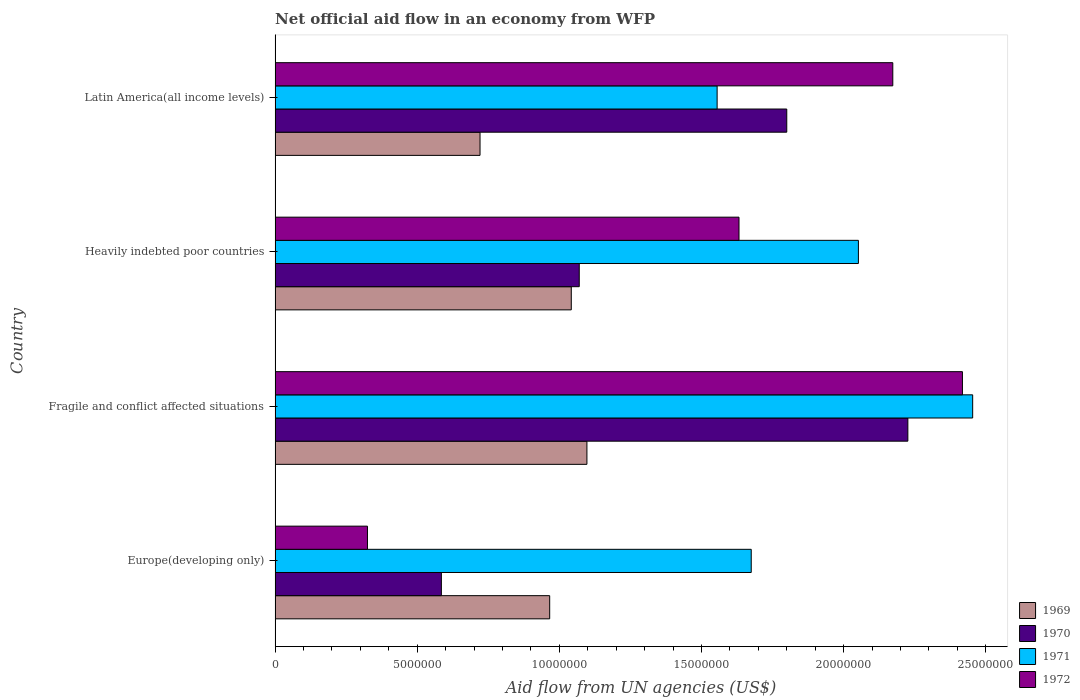How many different coloured bars are there?
Your answer should be very brief. 4. Are the number of bars per tick equal to the number of legend labels?
Ensure brevity in your answer.  Yes. Are the number of bars on each tick of the Y-axis equal?
Provide a short and direct response. Yes. How many bars are there on the 4th tick from the top?
Keep it short and to the point. 4. What is the label of the 1st group of bars from the top?
Offer a very short reply. Latin America(all income levels). In how many cases, is the number of bars for a given country not equal to the number of legend labels?
Your answer should be very brief. 0. What is the net official aid flow in 1969 in Latin America(all income levels)?
Keep it short and to the point. 7.21e+06. Across all countries, what is the maximum net official aid flow in 1972?
Provide a short and direct response. 2.42e+07. Across all countries, what is the minimum net official aid flow in 1969?
Your response must be concise. 7.21e+06. In which country was the net official aid flow in 1969 maximum?
Provide a succinct answer. Fragile and conflict affected situations. In which country was the net official aid flow in 1969 minimum?
Offer a terse response. Latin America(all income levels). What is the total net official aid flow in 1969 in the graph?
Provide a short and direct response. 3.83e+07. What is the difference between the net official aid flow in 1969 in Fragile and conflict affected situations and that in Latin America(all income levels)?
Your answer should be compact. 3.76e+06. What is the difference between the net official aid flow in 1969 in Heavily indebted poor countries and the net official aid flow in 1972 in Latin America(all income levels)?
Provide a succinct answer. -1.13e+07. What is the average net official aid flow in 1969 per country?
Provide a succinct answer. 9.56e+06. What is the difference between the net official aid flow in 1972 and net official aid flow in 1970 in Latin America(all income levels)?
Offer a very short reply. 3.73e+06. In how many countries, is the net official aid flow in 1971 greater than 8000000 US$?
Offer a very short reply. 4. What is the ratio of the net official aid flow in 1969 in Europe(developing only) to that in Fragile and conflict affected situations?
Your response must be concise. 0.88. Is the difference between the net official aid flow in 1972 in Heavily indebted poor countries and Latin America(all income levels) greater than the difference between the net official aid flow in 1970 in Heavily indebted poor countries and Latin America(all income levels)?
Your response must be concise. Yes. What is the difference between the highest and the second highest net official aid flow in 1970?
Make the answer very short. 4.26e+06. What is the difference between the highest and the lowest net official aid flow in 1970?
Your answer should be very brief. 1.64e+07. Is it the case that in every country, the sum of the net official aid flow in 1972 and net official aid flow in 1971 is greater than the sum of net official aid flow in 1970 and net official aid flow in 1969?
Your answer should be compact. No. What does the 4th bar from the top in Latin America(all income levels) represents?
Offer a very short reply. 1969. What does the 1st bar from the bottom in Heavily indebted poor countries represents?
Offer a terse response. 1969. How many bars are there?
Provide a succinct answer. 16. What is the difference between two consecutive major ticks on the X-axis?
Keep it short and to the point. 5.00e+06. Does the graph contain any zero values?
Provide a short and direct response. No. Where does the legend appear in the graph?
Make the answer very short. Bottom right. How are the legend labels stacked?
Provide a succinct answer. Vertical. What is the title of the graph?
Keep it short and to the point. Net official aid flow in an economy from WFP. What is the label or title of the X-axis?
Your response must be concise. Aid flow from UN agencies (US$). What is the label or title of the Y-axis?
Your response must be concise. Country. What is the Aid flow from UN agencies (US$) in 1969 in Europe(developing only)?
Make the answer very short. 9.66e+06. What is the Aid flow from UN agencies (US$) in 1970 in Europe(developing only)?
Your answer should be compact. 5.85e+06. What is the Aid flow from UN agencies (US$) of 1971 in Europe(developing only)?
Keep it short and to the point. 1.68e+07. What is the Aid flow from UN agencies (US$) of 1972 in Europe(developing only)?
Provide a succinct answer. 3.25e+06. What is the Aid flow from UN agencies (US$) in 1969 in Fragile and conflict affected situations?
Your answer should be very brief. 1.10e+07. What is the Aid flow from UN agencies (US$) of 1970 in Fragile and conflict affected situations?
Provide a short and direct response. 2.23e+07. What is the Aid flow from UN agencies (US$) in 1971 in Fragile and conflict affected situations?
Provide a succinct answer. 2.45e+07. What is the Aid flow from UN agencies (US$) of 1972 in Fragile and conflict affected situations?
Provide a short and direct response. 2.42e+07. What is the Aid flow from UN agencies (US$) in 1969 in Heavily indebted poor countries?
Make the answer very short. 1.04e+07. What is the Aid flow from UN agencies (US$) of 1970 in Heavily indebted poor countries?
Offer a terse response. 1.07e+07. What is the Aid flow from UN agencies (US$) of 1971 in Heavily indebted poor countries?
Ensure brevity in your answer.  2.05e+07. What is the Aid flow from UN agencies (US$) in 1972 in Heavily indebted poor countries?
Make the answer very short. 1.63e+07. What is the Aid flow from UN agencies (US$) in 1969 in Latin America(all income levels)?
Your response must be concise. 7.21e+06. What is the Aid flow from UN agencies (US$) of 1970 in Latin America(all income levels)?
Your answer should be compact. 1.80e+07. What is the Aid flow from UN agencies (US$) of 1971 in Latin America(all income levels)?
Make the answer very short. 1.56e+07. What is the Aid flow from UN agencies (US$) of 1972 in Latin America(all income levels)?
Provide a succinct answer. 2.17e+07. Across all countries, what is the maximum Aid flow from UN agencies (US$) in 1969?
Your answer should be compact. 1.10e+07. Across all countries, what is the maximum Aid flow from UN agencies (US$) in 1970?
Your answer should be very brief. 2.23e+07. Across all countries, what is the maximum Aid flow from UN agencies (US$) of 1971?
Offer a terse response. 2.45e+07. Across all countries, what is the maximum Aid flow from UN agencies (US$) of 1972?
Your answer should be very brief. 2.42e+07. Across all countries, what is the minimum Aid flow from UN agencies (US$) of 1969?
Provide a short and direct response. 7.21e+06. Across all countries, what is the minimum Aid flow from UN agencies (US$) in 1970?
Offer a very short reply. 5.85e+06. Across all countries, what is the minimum Aid flow from UN agencies (US$) of 1971?
Your answer should be compact. 1.56e+07. Across all countries, what is the minimum Aid flow from UN agencies (US$) of 1972?
Offer a very short reply. 3.25e+06. What is the total Aid flow from UN agencies (US$) in 1969 in the graph?
Give a very brief answer. 3.83e+07. What is the total Aid flow from UN agencies (US$) in 1970 in the graph?
Your answer should be very brief. 5.68e+07. What is the total Aid flow from UN agencies (US$) of 1971 in the graph?
Your answer should be very brief. 7.74e+07. What is the total Aid flow from UN agencies (US$) in 1972 in the graph?
Your answer should be very brief. 6.55e+07. What is the difference between the Aid flow from UN agencies (US$) of 1969 in Europe(developing only) and that in Fragile and conflict affected situations?
Your response must be concise. -1.31e+06. What is the difference between the Aid flow from UN agencies (US$) in 1970 in Europe(developing only) and that in Fragile and conflict affected situations?
Your answer should be compact. -1.64e+07. What is the difference between the Aid flow from UN agencies (US$) in 1971 in Europe(developing only) and that in Fragile and conflict affected situations?
Provide a succinct answer. -7.79e+06. What is the difference between the Aid flow from UN agencies (US$) of 1972 in Europe(developing only) and that in Fragile and conflict affected situations?
Offer a terse response. -2.09e+07. What is the difference between the Aid flow from UN agencies (US$) in 1969 in Europe(developing only) and that in Heavily indebted poor countries?
Your answer should be very brief. -7.60e+05. What is the difference between the Aid flow from UN agencies (US$) of 1970 in Europe(developing only) and that in Heavily indebted poor countries?
Make the answer very short. -4.85e+06. What is the difference between the Aid flow from UN agencies (US$) of 1971 in Europe(developing only) and that in Heavily indebted poor countries?
Provide a succinct answer. -3.77e+06. What is the difference between the Aid flow from UN agencies (US$) of 1972 in Europe(developing only) and that in Heavily indebted poor countries?
Ensure brevity in your answer.  -1.31e+07. What is the difference between the Aid flow from UN agencies (US$) of 1969 in Europe(developing only) and that in Latin America(all income levels)?
Provide a succinct answer. 2.45e+06. What is the difference between the Aid flow from UN agencies (US$) in 1970 in Europe(developing only) and that in Latin America(all income levels)?
Keep it short and to the point. -1.22e+07. What is the difference between the Aid flow from UN agencies (US$) in 1971 in Europe(developing only) and that in Latin America(all income levels)?
Give a very brief answer. 1.20e+06. What is the difference between the Aid flow from UN agencies (US$) of 1972 in Europe(developing only) and that in Latin America(all income levels)?
Your response must be concise. -1.85e+07. What is the difference between the Aid flow from UN agencies (US$) in 1969 in Fragile and conflict affected situations and that in Heavily indebted poor countries?
Keep it short and to the point. 5.50e+05. What is the difference between the Aid flow from UN agencies (US$) of 1970 in Fragile and conflict affected situations and that in Heavily indebted poor countries?
Your answer should be compact. 1.16e+07. What is the difference between the Aid flow from UN agencies (US$) in 1971 in Fragile and conflict affected situations and that in Heavily indebted poor countries?
Give a very brief answer. 4.02e+06. What is the difference between the Aid flow from UN agencies (US$) in 1972 in Fragile and conflict affected situations and that in Heavily indebted poor countries?
Keep it short and to the point. 7.86e+06. What is the difference between the Aid flow from UN agencies (US$) of 1969 in Fragile and conflict affected situations and that in Latin America(all income levels)?
Your response must be concise. 3.76e+06. What is the difference between the Aid flow from UN agencies (US$) of 1970 in Fragile and conflict affected situations and that in Latin America(all income levels)?
Provide a short and direct response. 4.26e+06. What is the difference between the Aid flow from UN agencies (US$) of 1971 in Fragile and conflict affected situations and that in Latin America(all income levels)?
Your answer should be compact. 8.99e+06. What is the difference between the Aid flow from UN agencies (US$) of 1972 in Fragile and conflict affected situations and that in Latin America(all income levels)?
Give a very brief answer. 2.45e+06. What is the difference between the Aid flow from UN agencies (US$) of 1969 in Heavily indebted poor countries and that in Latin America(all income levels)?
Give a very brief answer. 3.21e+06. What is the difference between the Aid flow from UN agencies (US$) of 1970 in Heavily indebted poor countries and that in Latin America(all income levels)?
Provide a succinct answer. -7.30e+06. What is the difference between the Aid flow from UN agencies (US$) in 1971 in Heavily indebted poor countries and that in Latin America(all income levels)?
Ensure brevity in your answer.  4.97e+06. What is the difference between the Aid flow from UN agencies (US$) of 1972 in Heavily indebted poor countries and that in Latin America(all income levels)?
Make the answer very short. -5.41e+06. What is the difference between the Aid flow from UN agencies (US$) in 1969 in Europe(developing only) and the Aid flow from UN agencies (US$) in 1970 in Fragile and conflict affected situations?
Offer a very short reply. -1.26e+07. What is the difference between the Aid flow from UN agencies (US$) of 1969 in Europe(developing only) and the Aid flow from UN agencies (US$) of 1971 in Fragile and conflict affected situations?
Keep it short and to the point. -1.49e+07. What is the difference between the Aid flow from UN agencies (US$) in 1969 in Europe(developing only) and the Aid flow from UN agencies (US$) in 1972 in Fragile and conflict affected situations?
Your answer should be compact. -1.45e+07. What is the difference between the Aid flow from UN agencies (US$) in 1970 in Europe(developing only) and the Aid flow from UN agencies (US$) in 1971 in Fragile and conflict affected situations?
Provide a short and direct response. -1.87e+07. What is the difference between the Aid flow from UN agencies (US$) in 1970 in Europe(developing only) and the Aid flow from UN agencies (US$) in 1972 in Fragile and conflict affected situations?
Your answer should be very brief. -1.83e+07. What is the difference between the Aid flow from UN agencies (US$) of 1971 in Europe(developing only) and the Aid flow from UN agencies (US$) of 1972 in Fragile and conflict affected situations?
Your response must be concise. -7.43e+06. What is the difference between the Aid flow from UN agencies (US$) of 1969 in Europe(developing only) and the Aid flow from UN agencies (US$) of 1970 in Heavily indebted poor countries?
Keep it short and to the point. -1.04e+06. What is the difference between the Aid flow from UN agencies (US$) of 1969 in Europe(developing only) and the Aid flow from UN agencies (US$) of 1971 in Heavily indebted poor countries?
Your answer should be compact. -1.09e+07. What is the difference between the Aid flow from UN agencies (US$) in 1969 in Europe(developing only) and the Aid flow from UN agencies (US$) in 1972 in Heavily indebted poor countries?
Your response must be concise. -6.66e+06. What is the difference between the Aid flow from UN agencies (US$) of 1970 in Europe(developing only) and the Aid flow from UN agencies (US$) of 1971 in Heavily indebted poor countries?
Your response must be concise. -1.47e+07. What is the difference between the Aid flow from UN agencies (US$) of 1970 in Europe(developing only) and the Aid flow from UN agencies (US$) of 1972 in Heavily indebted poor countries?
Provide a succinct answer. -1.05e+07. What is the difference between the Aid flow from UN agencies (US$) of 1969 in Europe(developing only) and the Aid flow from UN agencies (US$) of 1970 in Latin America(all income levels)?
Your answer should be compact. -8.34e+06. What is the difference between the Aid flow from UN agencies (US$) of 1969 in Europe(developing only) and the Aid flow from UN agencies (US$) of 1971 in Latin America(all income levels)?
Keep it short and to the point. -5.89e+06. What is the difference between the Aid flow from UN agencies (US$) of 1969 in Europe(developing only) and the Aid flow from UN agencies (US$) of 1972 in Latin America(all income levels)?
Ensure brevity in your answer.  -1.21e+07. What is the difference between the Aid flow from UN agencies (US$) of 1970 in Europe(developing only) and the Aid flow from UN agencies (US$) of 1971 in Latin America(all income levels)?
Give a very brief answer. -9.70e+06. What is the difference between the Aid flow from UN agencies (US$) in 1970 in Europe(developing only) and the Aid flow from UN agencies (US$) in 1972 in Latin America(all income levels)?
Offer a terse response. -1.59e+07. What is the difference between the Aid flow from UN agencies (US$) of 1971 in Europe(developing only) and the Aid flow from UN agencies (US$) of 1972 in Latin America(all income levels)?
Your answer should be compact. -4.98e+06. What is the difference between the Aid flow from UN agencies (US$) of 1969 in Fragile and conflict affected situations and the Aid flow from UN agencies (US$) of 1971 in Heavily indebted poor countries?
Your answer should be compact. -9.55e+06. What is the difference between the Aid flow from UN agencies (US$) of 1969 in Fragile and conflict affected situations and the Aid flow from UN agencies (US$) of 1972 in Heavily indebted poor countries?
Provide a succinct answer. -5.35e+06. What is the difference between the Aid flow from UN agencies (US$) of 1970 in Fragile and conflict affected situations and the Aid flow from UN agencies (US$) of 1971 in Heavily indebted poor countries?
Keep it short and to the point. 1.74e+06. What is the difference between the Aid flow from UN agencies (US$) of 1970 in Fragile and conflict affected situations and the Aid flow from UN agencies (US$) of 1972 in Heavily indebted poor countries?
Your answer should be compact. 5.94e+06. What is the difference between the Aid flow from UN agencies (US$) of 1971 in Fragile and conflict affected situations and the Aid flow from UN agencies (US$) of 1972 in Heavily indebted poor countries?
Your answer should be compact. 8.22e+06. What is the difference between the Aid flow from UN agencies (US$) of 1969 in Fragile and conflict affected situations and the Aid flow from UN agencies (US$) of 1970 in Latin America(all income levels)?
Keep it short and to the point. -7.03e+06. What is the difference between the Aid flow from UN agencies (US$) in 1969 in Fragile and conflict affected situations and the Aid flow from UN agencies (US$) in 1971 in Latin America(all income levels)?
Keep it short and to the point. -4.58e+06. What is the difference between the Aid flow from UN agencies (US$) in 1969 in Fragile and conflict affected situations and the Aid flow from UN agencies (US$) in 1972 in Latin America(all income levels)?
Your answer should be compact. -1.08e+07. What is the difference between the Aid flow from UN agencies (US$) in 1970 in Fragile and conflict affected situations and the Aid flow from UN agencies (US$) in 1971 in Latin America(all income levels)?
Offer a terse response. 6.71e+06. What is the difference between the Aid flow from UN agencies (US$) of 1970 in Fragile and conflict affected situations and the Aid flow from UN agencies (US$) of 1972 in Latin America(all income levels)?
Your response must be concise. 5.30e+05. What is the difference between the Aid flow from UN agencies (US$) in 1971 in Fragile and conflict affected situations and the Aid flow from UN agencies (US$) in 1972 in Latin America(all income levels)?
Provide a short and direct response. 2.81e+06. What is the difference between the Aid flow from UN agencies (US$) in 1969 in Heavily indebted poor countries and the Aid flow from UN agencies (US$) in 1970 in Latin America(all income levels)?
Make the answer very short. -7.58e+06. What is the difference between the Aid flow from UN agencies (US$) in 1969 in Heavily indebted poor countries and the Aid flow from UN agencies (US$) in 1971 in Latin America(all income levels)?
Provide a succinct answer. -5.13e+06. What is the difference between the Aid flow from UN agencies (US$) in 1969 in Heavily indebted poor countries and the Aid flow from UN agencies (US$) in 1972 in Latin America(all income levels)?
Offer a very short reply. -1.13e+07. What is the difference between the Aid flow from UN agencies (US$) in 1970 in Heavily indebted poor countries and the Aid flow from UN agencies (US$) in 1971 in Latin America(all income levels)?
Your answer should be compact. -4.85e+06. What is the difference between the Aid flow from UN agencies (US$) of 1970 in Heavily indebted poor countries and the Aid flow from UN agencies (US$) of 1972 in Latin America(all income levels)?
Give a very brief answer. -1.10e+07. What is the difference between the Aid flow from UN agencies (US$) in 1971 in Heavily indebted poor countries and the Aid flow from UN agencies (US$) in 1972 in Latin America(all income levels)?
Your response must be concise. -1.21e+06. What is the average Aid flow from UN agencies (US$) in 1969 per country?
Your response must be concise. 9.56e+06. What is the average Aid flow from UN agencies (US$) of 1970 per country?
Offer a very short reply. 1.42e+07. What is the average Aid flow from UN agencies (US$) of 1971 per country?
Offer a very short reply. 1.93e+07. What is the average Aid flow from UN agencies (US$) in 1972 per country?
Provide a short and direct response. 1.64e+07. What is the difference between the Aid flow from UN agencies (US$) of 1969 and Aid flow from UN agencies (US$) of 1970 in Europe(developing only)?
Offer a terse response. 3.81e+06. What is the difference between the Aid flow from UN agencies (US$) in 1969 and Aid flow from UN agencies (US$) in 1971 in Europe(developing only)?
Keep it short and to the point. -7.09e+06. What is the difference between the Aid flow from UN agencies (US$) in 1969 and Aid flow from UN agencies (US$) in 1972 in Europe(developing only)?
Make the answer very short. 6.41e+06. What is the difference between the Aid flow from UN agencies (US$) in 1970 and Aid flow from UN agencies (US$) in 1971 in Europe(developing only)?
Offer a very short reply. -1.09e+07. What is the difference between the Aid flow from UN agencies (US$) of 1970 and Aid flow from UN agencies (US$) of 1972 in Europe(developing only)?
Provide a succinct answer. 2.60e+06. What is the difference between the Aid flow from UN agencies (US$) in 1971 and Aid flow from UN agencies (US$) in 1972 in Europe(developing only)?
Keep it short and to the point. 1.35e+07. What is the difference between the Aid flow from UN agencies (US$) in 1969 and Aid flow from UN agencies (US$) in 1970 in Fragile and conflict affected situations?
Your answer should be very brief. -1.13e+07. What is the difference between the Aid flow from UN agencies (US$) of 1969 and Aid flow from UN agencies (US$) of 1971 in Fragile and conflict affected situations?
Your response must be concise. -1.36e+07. What is the difference between the Aid flow from UN agencies (US$) of 1969 and Aid flow from UN agencies (US$) of 1972 in Fragile and conflict affected situations?
Keep it short and to the point. -1.32e+07. What is the difference between the Aid flow from UN agencies (US$) of 1970 and Aid flow from UN agencies (US$) of 1971 in Fragile and conflict affected situations?
Make the answer very short. -2.28e+06. What is the difference between the Aid flow from UN agencies (US$) of 1970 and Aid flow from UN agencies (US$) of 1972 in Fragile and conflict affected situations?
Provide a short and direct response. -1.92e+06. What is the difference between the Aid flow from UN agencies (US$) in 1969 and Aid flow from UN agencies (US$) in 1970 in Heavily indebted poor countries?
Ensure brevity in your answer.  -2.80e+05. What is the difference between the Aid flow from UN agencies (US$) in 1969 and Aid flow from UN agencies (US$) in 1971 in Heavily indebted poor countries?
Your answer should be very brief. -1.01e+07. What is the difference between the Aid flow from UN agencies (US$) in 1969 and Aid flow from UN agencies (US$) in 1972 in Heavily indebted poor countries?
Give a very brief answer. -5.90e+06. What is the difference between the Aid flow from UN agencies (US$) in 1970 and Aid flow from UN agencies (US$) in 1971 in Heavily indebted poor countries?
Make the answer very short. -9.82e+06. What is the difference between the Aid flow from UN agencies (US$) of 1970 and Aid flow from UN agencies (US$) of 1972 in Heavily indebted poor countries?
Your answer should be very brief. -5.62e+06. What is the difference between the Aid flow from UN agencies (US$) in 1971 and Aid flow from UN agencies (US$) in 1972 in Heavily indebted poor countries?
Offer a terse response. 4.20e+06. What is the difference between the Aid flow from UN agencies (US$) in 1969 and Aid flow from UN agencies (US$) in 1970 in Latin America(all income levels)?
Your answer should be compact. -1.08e+07. What is the difference between the Aid flow from UN agencies (US$) of 1969 and Aid flow from UN agencies (US$) of 1971 in Latin America(all income levels)?
Provide a succinct answer. -8.34e+06. What is the difference between the Aid flow from UN agencies (US$) of 1969 and Aid flow from UN agencies (US$) of 1972 in Latin America(all income levels)?
Offer a very short reply. -1.45e+07. What is the difference between the Aid flow from UN agencies (US$) of 1970 and Aid flow from UN agencies (US$) of 1971 in Latin America(all income levels)?
Ensure brevity in your answer.  2.45e+06. What is the difference between the Aid flow from UN agencies (US$) of 1970 and Aid flow from UN agencies (US$) of 1972 in Latin America(all income levels)?
Your answer should be very brief. -3.73e+06. What is the difference between the Aid flow from UN agencies (US$) in 1971 and Aid flow from UN agencies (US$) in 1972 in Latin America(all income levels)?
Give a very brief answer. -6.18e+06. What is the ratio of the Aid flow from UN agencies (US$) of 1969 in Europe(developing only) to that in Fragile and conflict affected situations?
Offer a very short reply. 0.88. What is the ratio of the Aid flow from UN agencies (US$) of 1970 in Europe(developing only) to that in Fragile and conflict affected situations?
Give a very brief answer. 0.26. What is the ratio of the Aid flow from UN agencies (US$) of 1971 in Europe(developing only) to that in Fragile and conflict affected situations?
Your answer should be very brief. 0.68. What is the ratio of the Aid flow from UN agencies (US$) in 1972 in Europe(developing only) to that in Fragile and conflict affected situations?
Your answer should be compact. 0.13. What is the ratio of the Aid flow from UN agencies (US$) in 1969 in Europe(developing only) to that in Heavily indebted poor countries?
Provide a short and direct response. 0.93. What is the ratio of the Aid flow from UN agencies (US$) in 1970 in Europe(developing only) to that in Heavily indebted poor countries?
Your response must be concise. 0.55. What is the ratio of the Aid flow from UN agencies (US$) of 1971 in Europe(developing only) to that in Heavily indebted poor countries?
Offer a very short reply. 0.82. What is the ratio of the Aid flow from UN agencies (US$) of 1972 in Europe(developing only) to that in Heavily indebted poor countries?
Your response must be concise. 0.2. What is the ratio of the Aid flow from UN agencies (US$) of 1969 in Europe(developing only) to that in Latin America(all income levels)?
Provide a succinct answer. 1.34. What is the ratio of the Aid flow from UN agencies (US$) in 1970 in Europe(developing only) to that in Latin America(all income levels)?
Your response must be concise. 0.33. What is the ratio of the Aid flow from UN agencies (US$) of 1971 in Europe(developing only) to that in Latin America(all income levels)?
Offer a very short reply. 1.08. What is the ratio of the Aid flow from UN agencies (US$) in 1972 in Europe(developing only) to that in Latin America(all income levels)?
Your answer should be very brief. 0.15. What is the ratio of the Aid flow from UN agencies (US$) in 1969 in Fragile and conflict affected situations to that in Heavily indebted poor countries?
Your response must be concise. 1.05. What is the ratio of the Aid flow from UN agencies (US$) of 1970 in Fragile and conflict affected situations to that in Heavily indebted poor countries?
Give a very brief answer. 2.08. What is the ratio of the Aid flow from UN agencies (US$) in 1971 in Fragile and conflict affected situations to that in Heavily indebted poor countries?
Your answer should be compact. 1.2. What is the ratio of the Aid flow from UN agencies (US$) in 1972 in Fragile and conflict affected situations to that in Heavily indebted poor countries?
Your answer should be very brief. 1.48. What is the ratio of the Aid flow from UN agencies (US$) of 1969 in Fragile and conflict affected situations to that in Latin America(all income levels)?
Your answer should be compact. 1.52. What is the ratio of the Aid flow from UN agencies (US$) in 1970 in Fragile and conflict affected situations to that in Latin America(all income levels)?
Keep it short and to the point. 1.24. What is the ratio of the Aid flow from UN agencies (US$) in 1971 in Fragile and conflict affected situations to that in Latin America(all income levels)?
Your answer should be compact. 1.58. What is the ratio of the Aid flow from UN agencies (US$) in 1972 in Fragile and conflict affected situations to that in Latin America(all income levels)?
Ensure brevity in your answer.  1.11. What is the ratio of the Aid flow from UN agencies (US$) of 1969 in Heavily indebted poor countries to that in Latin America(all income levels)?
Give a very brief answer. 1.45. What is the ratio of the Aid flow from UN agencies (US$) of 1970 in Heavily indebted poor countries to that in Latin America(all income levels)?
Give a very brief answer. 0.59. What is the ratio of the Aid flow from UN agencies (US$) of 1971 in Heavily indebted poor countries to that in Latin America(all income levels)?
Offer a very short reply. 1.32. What is the ratio of the Aid flow from UN agencies (US$) in 1972 in Heavily indebted poor countries to that in Latin America(all income levels)?
Keep it short and to the point. 0.75. What is the difference between the highest and the second highest Aid flow from UN agencies (US$) of 1969?
Offer a very short reply. 5.50e+05. What is the difference between the highest and the second highest Aid flow from UN agencies (US$) of 1970?
Provide a short and direct response. 4.26e+06. What is the difference between the highest and the second highest Aid flow from UN agencies (US$) of 1971?
Your answer should be compact. 4.02e+06. What is the difference between the highest and the second highest Aid flow from UN agencies (US$) of 1972?
Offer a very short reply. 2.45e+06. What is the difference between the highest and the lowest Aid flow from UN agencies (US$) in 1969?
Keep it short and to the point. 3.76e+06. What is the difference between the highest and the lowest Aid flow from UN agencies (US$) of 1970?
Offer a very short reply. 1.64e+07. What is the difference between the highest and the lowest Aid flow from UN agencies (US$) in 1971?
Offer a very short reply. 8.99e+06. What is the difference between the highest and the lowest Aid flow from UN agencies (US$) of 1972?
Provide a short and direct response. 2.09e+07. 